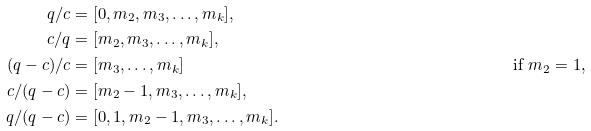<formula> <loc_0><loc_0><loc_500><loc_500>q / c & = [ 0 , m _ { 2 } , m _ { 3 } , \dots , m _ { k } ] , \\ c / q & = [ m _ { 2 } , m _ { 3 } , \dots , m _ { k } ] , \\ ( q - c ) / c & = [ m _ { 3 } , \dots , m _ { k } ] & \text {if $m_{2}=1$,} \quad \\ c / ( q - c ) & = [ m _ { 2 } - 1 , m _ { 3 } , \dots , m _ { k } ] , \\ q / ( q - c ) & = [ 0 , 1 , m _ { 2 } - 1 , m _ { 3 } , \dots , m _ { k } ] .</formula> 